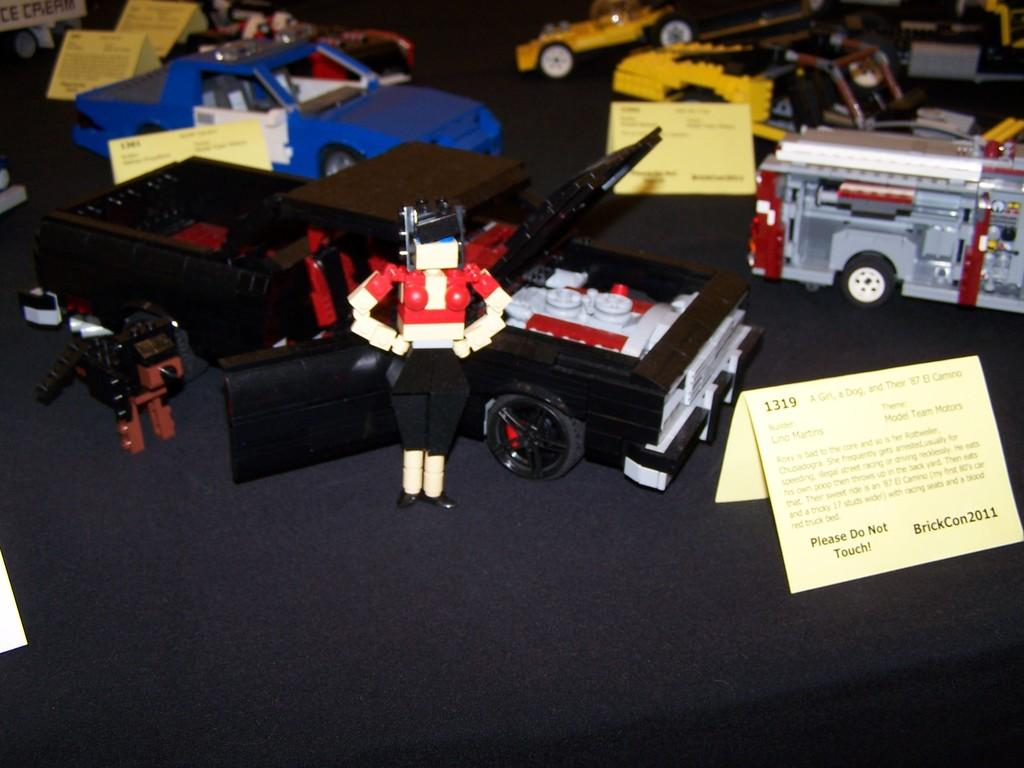<image>
Share a concise interpretation of the image provided. Some action figures and vehicles and a sign reading Do Not Touch. 